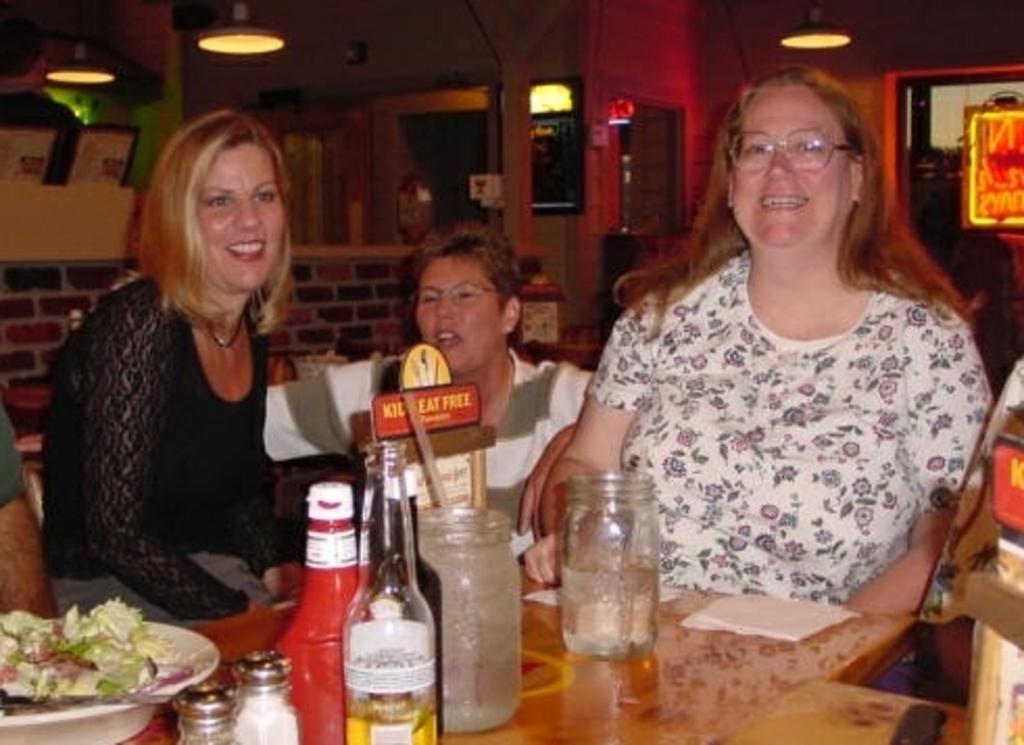Describe this image in one or two sentences. This image is taken in a restaurant. There are four people in this restaurant. At the bottom of the image there is a table on which there were a bowl of food, salt bottle, pepper bottle, wine bottle, a jar and a board with text on it. At the right side of the image a woman is sitting on a chair. In the left side of the image a woman is sitting. On the top of the image there were few lights. At the background there is a wall. 